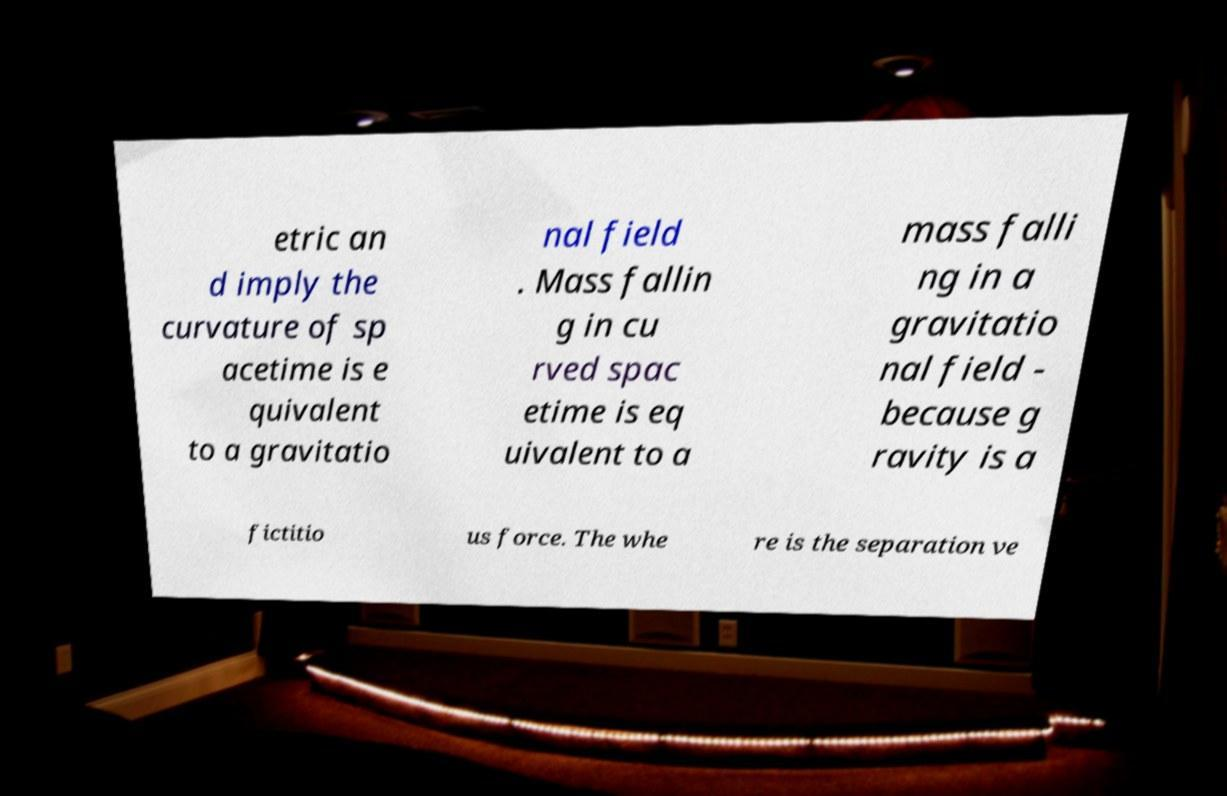Could you extract and type out the text from this image? etric an d imply the curvature of sp acetime is e quivalent to a gravitatio nal field . Mass fallin g in cu rved spac etime is eq uivalent to a mass falli ng in a gravitatio nal field - because g ravity is a fictitio us force. The whe re is the separation ve 